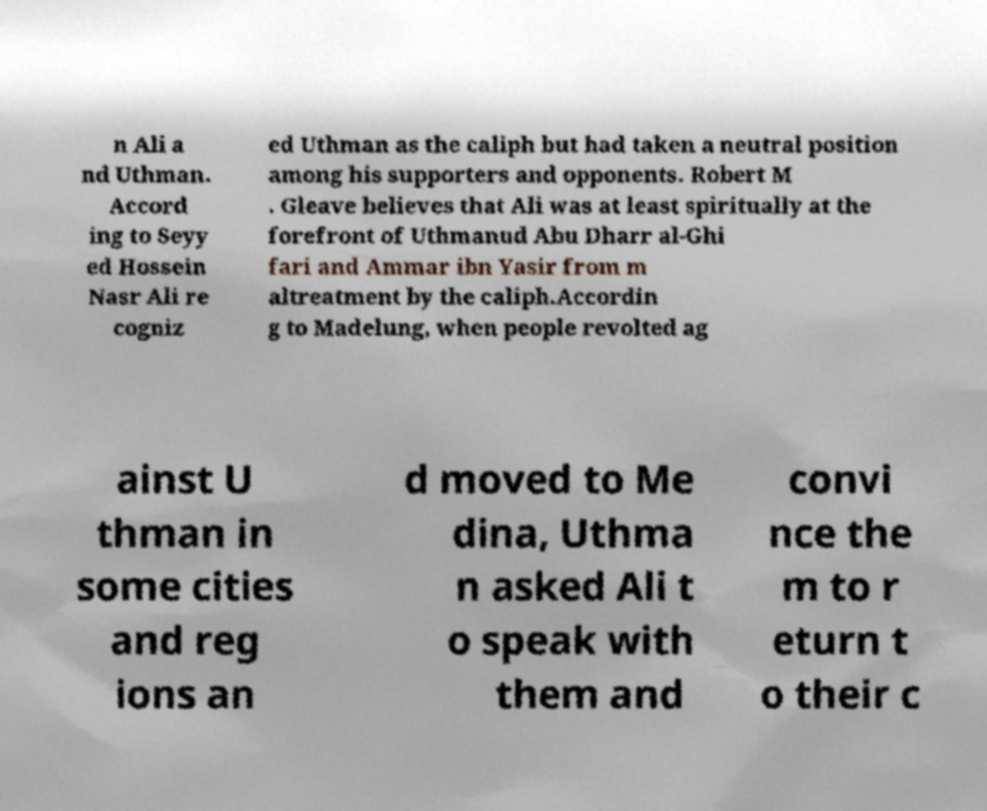Could you extract and type out the text from this image? n Ali a nd Uthman. Accord ing to Seyy ed Hossein Nasr Ali re cogniz ed Uthman as the caliph but had taken a neutral position among his supporters and opponents. Robert M . Gleave believes that Ali was at least spiritually at the forefront of Uthmanud Abu Dharr al-Ghi fari and Ammar ibn Yasir from m altreatment by the caliph.Accordin g to Madelung, when people revolted ag ainst U thman in some cities and reg ions an d moved to Me dina, Uthma n asked Ali t o speak with them and convi nce the m to r eturn t o their c 